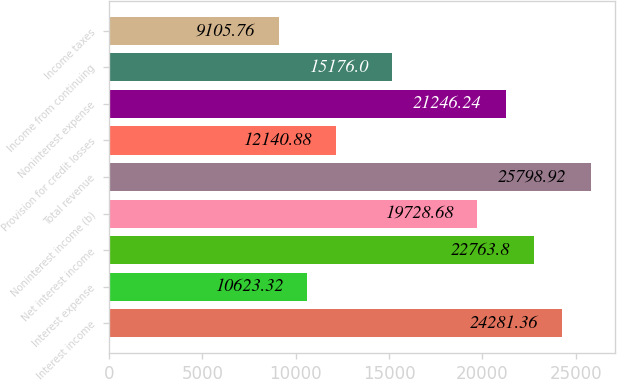<chart> <loc_0><loc_0><loc_500><loc_500><bar_chart><fcel>Interest income<fcel>Interest expense<fcel>Net interest income<fcel>Noninterest income (b)<fcel>Total revenue<fcel>Provision for credit losses<fcel>Noninterest expense<fcel>Income from continuing<fcel>Income taxes<nl><fcel>24281.4<fcel>10623.3<fcel>22763.8<fcel>19728.7<fcel>25798.9<fcel>12140.9<fcel>21246.2<fcel>15176<fcel>9105.76<nl></chart> 